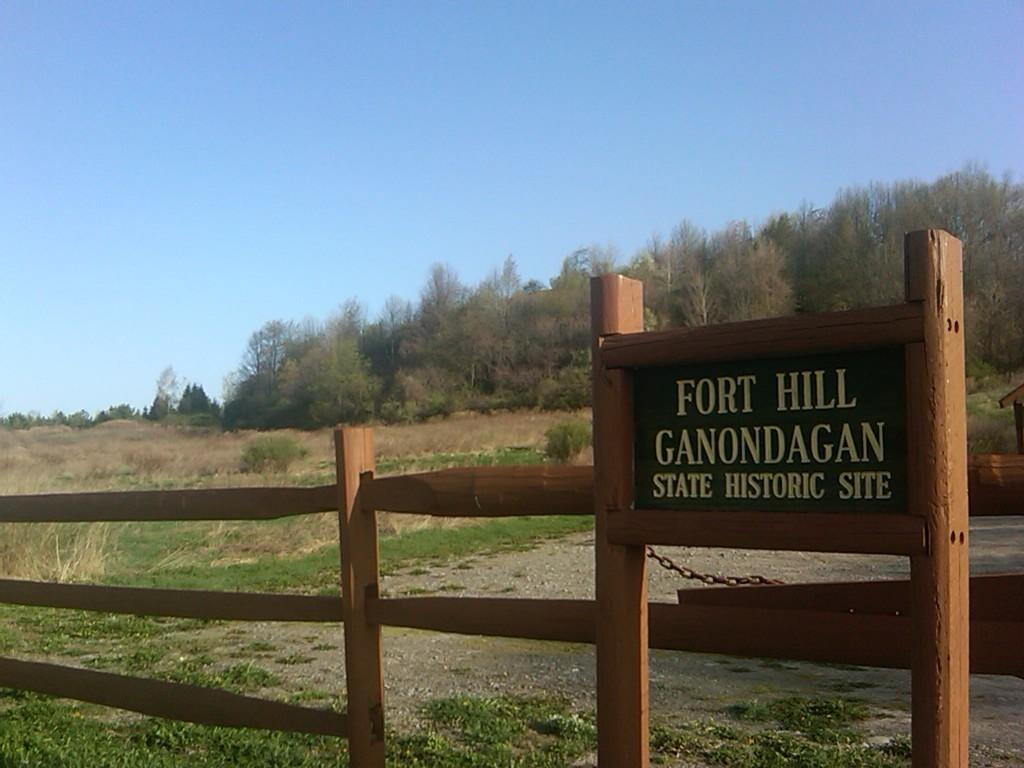What type of structure can be seen in the image? There is a fence in the image. Is there anything attached to the fence? Yes, there is a board attached to the fence. What can be found on the board? There is text written on the board. What can be seen behind the fence? Trees, plants, and bushes are present behind the fence. What activity is the cat participating in behind the fence? There is no cat present in the image, so it is not possible to answer that question. 